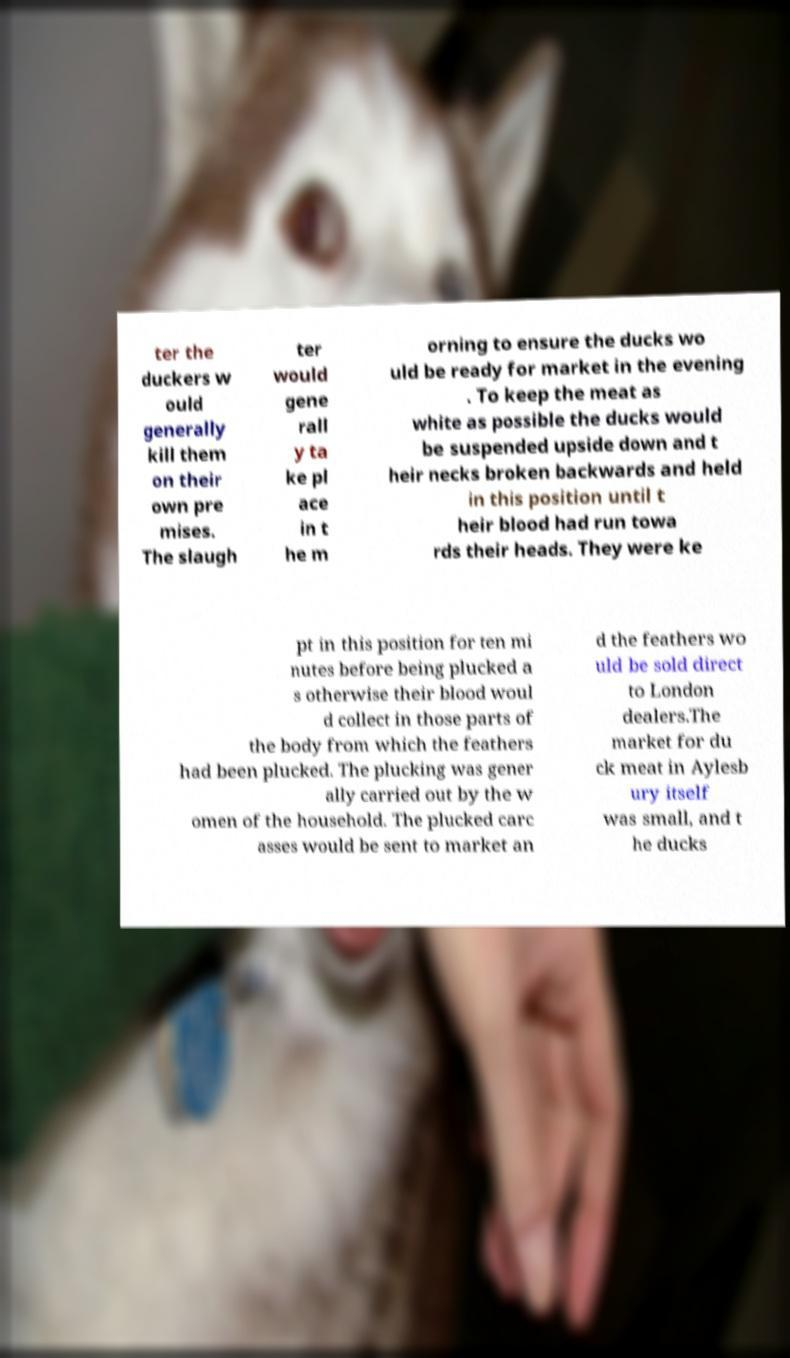Can you accurately transcribe the text from the provided image for me? ter the duckers w ould generally kill them on their own pre mises. The slaugh ter would gene rall y ta ke pl ace in t he m orning to ensure the ducks wo uld be ready for market in the evening . To keep the meat as white as possible the ducks would be suspended upside down and t heir necks broken backwards and held in this position until t heir blood had run towa rds their heads. They were ke pt in this position for ten mi nutes before being plucked a s otherwise their blood woul d collect in those parts of the body from which the feathers had been plucked. The plucking was gener ally carried out by the w omen of the household. The plucked carc asses would be sent to market an d the feathers wo uld be sold direct to London dealers.The market for du ck meat in Aylesb ury itself was small, and t he ducks 